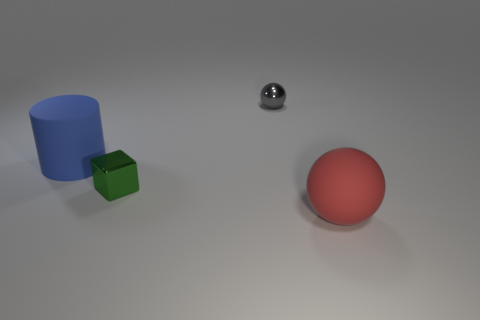If I wanted to make the red sphere stand out more, what changes could be made in the scene? To make the red sphere stand out, one could increase the saturation of its color or adjust the lighting to cast a spotlight on it. Additionally, removing or rearranging other objects to provide a clean background contrast or changing their colors to a less dominant palette would also help the red sphere be more prominent. 